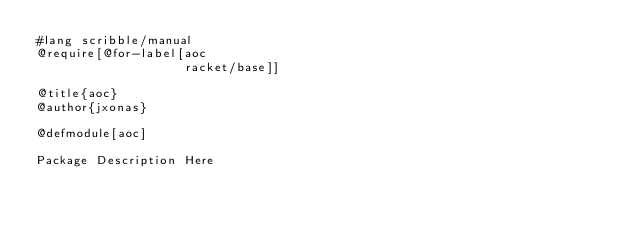Convert code to text. <code><loc_0><loc_0><loc_500><loc_500><_Racket_>#lang scribble/manual
@require[@for-label[aoc
                    racket/base]]

@title{aoc}
@author{jxonas}

@defmodule[aoc]

Package Description Here
</code> 